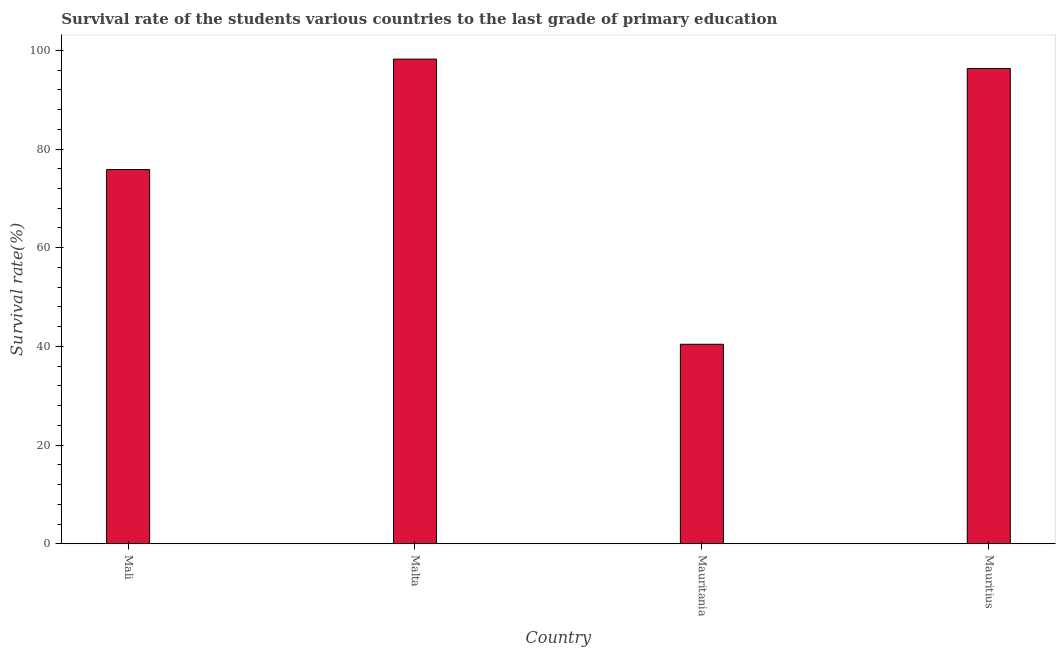What is the title of the graph?
Your answer should be compact. Survival rate of the students various countries to the last grade of primary education. What is the label or title of the Y-axis?
Your answer should be compact. Survival rate(%). What is the survival rate in primary education in Mauritius?
Keep it short and to the point. 96.32. Across all countries, what is the maximum survival rate in primary education?
Keep it short and to the point. 98.23. Across all countries, what is the minimum survival rate in primary education?
Make the answer very short. 40.43. In which country was the survival rate in primary education maximum?
Provide a succinct answer. Malta. In which country was the survival rate in primary education minimum?
Ensure brevity in your answer.  Mauritania. What is the sum of the survival rate in primary education?
Ensure brevity in your answer.  310.82. What is the difference between the survival rate in primary education in Mauritania and Mauritius?
Give a very brief answer. -55.89. What is the average survival rate in primary education per country?
Offer a very short reply. 77.7. What is the median survival rate in primary education?
Keep it short and to the point. 86.08. What is the ratio of the survival rate in primary education in Mali to that in Malta?
Ensure brevity in your answer.  0.77. Is the difference between the survival rate in primary education in Mali and Mauritania greater than the difference between any two countries?
Keep it short and to the point. No. What is the difference between the highest and the second highest survival rate in primary education?
Provide a short and direct response. 1.91. What is the difference between the highest and the lowest survival rate in primary education?
Make the answer very short. 57.8. How many bars are there?
Make the answer very short. 4. How many countries are there in the graph?
Your answer should be very brief. 4. What is the difference between two consecutive major ticks on the Y-axis?
Provide a short and direct response. 20. Are the values on the major ticks of Y-axis written in scientific E-notation?
Your response must be concise. No. What is the Survival rate(%) in Mali?
Provide a short and direct response. 75.84. What is the Survival rate(%) of Malta?
Your response must be concise. 98.23. What is the Survival rate(%) in Mauritania?
Your answer should be compact. 40.43. What is the Survival rate(%) of Mauritius?
Ensure brevity in your answer.  96.32. What is the difference between the Survival rate(%) in Mali and Malta?
Give a very brief answer. -22.38. What is the difference between the Survival rate(%) in Mali and Mauritania?
Keep it short and to the point. 35.41. What is the difference between the Survival rate(%) in Mali and Mauritius?
Your answer should be compact. -20.48. What is the difference between the Survival rate(%) in Malta and Mauritania?
Ensure brevity in your answer.  57.8. What is the difference between the Survival rate(%) in Malta and Mauritius?
Provide a succinct answer. 1.91. What is the difference between the Survival rate(%) in Mauritania and Mauritius?
Your answer should be very brief. -55.89. What is the ratio of the Survival rate(%) in Mali to that in Malta?
Ensure brevity in your answer.  0.77. What is the ratio of the Survival rate(%) in Mali to that in Mauritania?
Provide a short and direct response. 1.88. What is the ratio of the Survival rate(%) in Mali to that in Mauritius?
Offer a very short reply. 0.79. What is the ratio of the Survival rate(%) in Malta to that in Mauritania?
Your response must be concise. 2.43. What is the ratio of the Survival rate(%) in Malta to that in Mauritius?
Offer a very short reply. 1.02. What is the ratio of the Survival rate(%) in Mauritania to that in Mauritius?
Offer a very short reply. 0.42. 